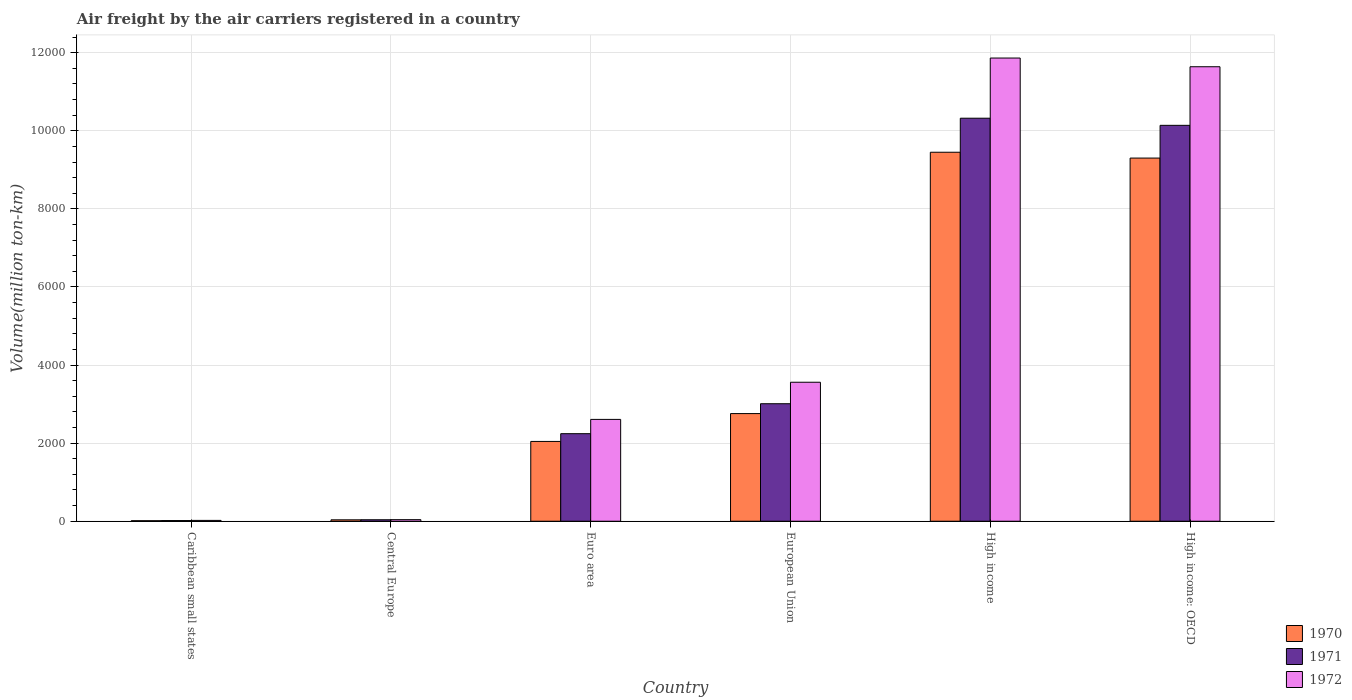How many different coloured bars are there?
Your response must be concise. 3. Are the number of bars per tick equal to the number of legend labels?
Provide a succinct answer. Yes. How many bars are there on the 5th tick from the left?
Your response must be concise. 3. What is the label of the 6th group of bars from the left?
Offer a very short reply. High income: OECD. In how many cases, is the number of bars for a given country not equal to the number of legend labels?
Your response must be concise. 0. What is the volume of the air carriers in 1971 in Euro area?
Make the answer very short. 2242.1. Across all countries, what is the maximum volume of the air carriers in 1972?
Offer a terse response. 1.19e+04. Across all countries, what is the minimum volume of the air carriers in 1972?
Give a very brief answer. 21.4. In which country was the volume of the air carriers in 1972 maximum?
Your answer should be compact. High income. In which country was the volume of the air carriers in 1972 minimum?
Give a very brief answer. Caribbean small states. What is the total volume of the air carriers in 1970 in the graph?
Offer a very short reply. 2.36e+04. What is the difference between the volume of the air carriers in 1971 in Caribbean small states and that in High income: OECD?
Your answer should be compact. -1.01e+04. What is the difference between the volume of the air carriers in 1970 in Caribbean small states and the volume of the air carriers in 1972 in Central Europe?
Your answer should be very brief. -26.7. What is the average volume of the air carriers in 1971 per country?
Your answer should be very brief. 4294.62. What is the difference between the volume of the air carriers of/in 1970 and volume of the air carriers of/in 1971 in European Union?
Offer a very short reply. -252.6. In how many countries, is the volume of the air carriers in 1970 greater than 8000 million ton-km?
Your response must be concise. 2. What is the ratio of the volume of the air carriers in 1972 in High income to that in High income: OECD?
Your answer should be compact. 1.02. Is the volume of the air carriers in 1971 in Central Europe less than that in Euro area?
Offer a very short reply. Yes. What is the difference between the highest and the second highest volume of the air carriers in 1971?
Your answer should be very brief. 182.7. What is the difference between the highest and the lowest volume of the air carriers in 1972?
Your response must be concise. 1.18e+04. In how many countries, is the volume of the air carriers in 1970 greater than the average volume of the air carriers in 1970 taken over all countries?
Offer a terse response. 2. Is it the case that in every country, the sum of the volume of the air carriers in 1972 and volume of the air carriers in 1970 is greater than the volume of the air carriers in 1971?
Ensure brevity in your answer.  Yes. Are all the bars in the graph horizontal?
Your response must be concise. No. Are the values on the major ticks of Y-axis written in scientific E-notation?
Keep it short and to the point. No. Does the graph contain grids?
Ensure brevity in your answer.  Yes. How are the legend labels stacked?
Give a very brief answer. Vertical. What is the title of the graph?
Offer a terse response. Air freight by the air carriers registered in a country. What is the label or title of the X-axis?
Offer a very short reply. Country. What is the label or title of the Y-axis?
Your response must be concise. Volume(million ton-km). What is the Volume(million ton-km) of 1970 in Caribbean small states?
Your answer should be compact. 13.4. What is the Volume(million ton-km) of 1971 in Caribbean small states?
Provide a succinct answer. 17.2. What is the Volume(million ton-km) in 1972 in Caribbean small states?
Offer a very short reply. 21.4. What is the Volume(million ton-km) of 1970 in Central Europe?
Provide a succinct answer. 36. What is the Volume(million ton-km) in 1971 in Central Europe?
Give a very brief answer. 37.9. What is the Volume(million ton-km) of 1972 in Central Europe?
Offer a very short reply. 40.1. What is the Volume(million ton-km) of 1970 in Euro area?
Your response must be concise. 2043.6. What is the Volume(million ton-km) of 1971 in Euro area?
Ensure brevity in your answer.  2242.1. What is the Volume(million ton-km) of 1972 in Euro area?
Your answer should be very brief. 2607.9. What is the Volume(million ton-km) of 1970 in European Union?
Make the answer very short. 2756.8. What is the Volume(million ton-km) of 1971 in European Union?
Give a very brief answer. 3009.4. What is the Volume(million ton-km) in 1972 in European Union?
Give a very brief answer. 3559.6. What is the Volume(million ton-km) of 1970 in High income?
Your answer should be very brief. 9450. What is the Volume(million ton-km) in 1971 in High income?
Your response must be concise. 1.03e+04. What is the Volume(million ton-km) of 1972 in High income?
Ensure brevity in your answer.  1.19e+04. What is the Volume(million ton-km) of 1970 in High income: OECD?
Make the answer very short. 9300.9. What is the Volume(million ton-km) in 1971 in High income: OECD?
Your response must be concise. 1.01e+04. What is the Volume(million ton-km) in 1972 in High income: OECD?
Your answer should be compact. 1.16e+04. Across all countries, what is the maximum Volume(million ton-km) in 1970?
Give a very brief answer. 9450. Across all countries, what is the maximum Volume(million ton-km) in 1971?
Give a very brief answer. 1.03e+04. Across all countries, what is the maximum Volume(million ton-km) in 1972?
Keep it short and to the point. 1.19e+04. Across all countries, what is the minimum Volume(million ton-km) of 1970?
Give a very brief answer. 13.4. Across all countries, what is the minimum Volume(million ton-km) in 1971?
Your response must be concise. 17.2. Across all countries, what is the minimum Volume(million ton-km) in 1972?
Ensure brevity in your answer.  21.4. What is the total Volume(million ton-km) in 1970 in the graph?
Your answer should be compact. 2.36e+04. What is the total Volume(million ton-km) in 1971 in the graph?
Your answer should be very brief. 2.58e+04. What is the total Volume(million ton-km) in 1972 in the graph?
Offer a very short reply. 2.97e+04. What is the difference between the Volume(million ton-km) of 1970 in Caribbean small states and that in Central Europe?
Make the answer very short. -22.6. What is the difference between the Volume(million ton-km) in 1971 in Caribbean small states and that in Central Europe?
Provide a succinct answer. -20.7. What is the difference between the Volume(million ton-km) of 1972 in Caribbean small states and that in Central Europe?
Make the answer very short. -18.7. What is the difference between the Volume(million ton-km) in 1970 in Caribbean small states and that in Euro area?
Your answer should be compact. -2030.2. What is the difference between the Volume(million ton-km) in 1971 in Caribbean small states and that in Euro area?
Provide a succinct answer. -2224.9. What is the difference between the Volume(million ton-km) of 1972 in Caribbean small states and that in Euro area?
Give a very brief answer. -2586.5. What is the difference between the Volume(million ton-km) of 1970 in Caribbean small states and that in European Union?
Keep it short and to the point. -2743.4. What is the difference between the Volume(million ton-km) of 1971 in Caribbean small states and that in European Union?
Offer a very short reply. -2992.2. What is the difference between the Volume(million ton-km) in 1972 in Caribbean small states and that in European Union?
Ensure brevity in your answer.  -3538.2. What is the difference between the Volume(million ton-km) in 1970 in Caribbean small states and that in High income?
Keep it short and to the point. -9436.6. What is the difference between the Volume(million ton-km) of 1971 in Caribbean small states and that in High income?
Your answer should be compact. -1.03e+04. What is the difference between the Volume(million ton-km) in 1972 in Caribbean small states and that in High income?
Provide a short and direct response. -1.18e+04. What is the difference between the Volume(million ton-km) of 1970 in Caribbean small states and that in High income: OECD?
Your response must be concise. -9287.5. What is the difference between the Volume(million ton-km) in 1971 in Caribbean small states and that in High income: OECD?
Offer a very short reply. -1.01e+04. What is the difference between the Volume(million ton-km) of 1972 in Caribbean small states and that in High income: OECD?
Your response must be concise. -1.16e+04. What is the difference between the Volume(million ton-km) in 1970 in Central Europe and that in Euro area?
Make the answer very short. -2007.6. What is the difference between the Volume(million ton-km) in 1971 in Central Europe and that in Euro area?
Keep it short and to the point. -2204.2. What is the difference between the Volume(million ton-km) in 1972 in Central Europe and that in Euro area?
Offer a terse response. -2567.8. What is the difference between the Volume(million ton-km) of 1970 in Central Europe and that in European Union?
Provide a succinct answer. -2720.8. What is the difference between the Volume(million ton-km) in 1971 in Central Europe and that in European Union?
Your response must be concise. -2971.5. What is the difference between the Volume(million ton-km) of 1972 in Central Europe and that in European Union?
Provide a succinct answer. -3519.5. What is the difference between the Volume(million ton-km) of 1970 in Central Europe and that in High income?
Provide a short and direct response. -9414. What is the difference between the Volume(million ton-km) of 1971 in Central Europe and that in High income?
Ensure brevity in your answer.  -1.03e+04. What is the difference between the Volume(million ton-km) in 1972 in Central Europe and that in High income?
Keep it short and to the point. -1.18e+04. What is the difference between the Volume(million ton-km) of 1970 in Central Europe and that in High income: OECD?
Keep it short and to the point. -9264.9. What is the difference between the Volume(million ton-km) in 1971 in Central Europe and that in High income: OECD?
Your answer should be compact. -1.01e+04. What is the difference between the Volume(million ton-km) of 1972 in Central Europe and that in High income: OECD?
Keep it short and to the point. -1.16e+04. What is the difference between the Volume(million ton-km) of 1970 in Euro area and that in European Union?
Make the answer very short. -713.2. What is the difference between the Volume(million ton-km) in 1971 in Euro area and that in European Union?
Give a very brief answer. -767.3. What is the difference between the Volume(million ton-km) in 1972 in Euro area and that in European Union?
Keep it short and to the point. -951.7. What is the difference between the Volume(million ton-km) of 1970 in Euro area and that in High income?
Provide a succinct answer. -7406.4. What is the difference between the Volume(million ton-km) in 1971 in Euro area and that in High income?
Keep it short and to the point. -8079.8. What is the difference between the Volume(million ton-km) in 1972 in Euro area and that in High income?
Make the answer very short. -9255. What is the difference between the Volume(million ton-km) in 1970 in Euro area and that in High income: OECD?
Make the answer very short. -7257.3. What is the difference between the Volume(million ton-km) in 1971 in Euro area and that in High income: OECD?
Provide a succinct answer. -7897.1. What is the difference between the Volume(million ton-km) of 1972 in Euro area and that in High income: OECD?
Offer a terse response. -9031.8. What is the difference between the Volume(million ton-km) of 1970 in European Union and that in High income?
Keep it short and to the point. -6693.2. What is the difference between the Volume(million ton-km) of 1971 in European Union and that in High income?
Your response must be concise. -7312.5. What is the difference between the Volume(million ton-km) of 1972 in European Union and that in High income?
Offer a very short reply. -8303.3. What is the difference between the Volume(million ton-km) in 1970 in European Union and that in High income: OECD?
Your response must be concise. -6544.1. What is the difference between the Volume(million ton-km) in 1971 in European Union and that in High income: OECD?
Offer a very short reply. -7129.8. What is the difference between the Volume(million ton-km) in 1972 in European Union and that in High income: OECD?
Provide a succinct answer. -8080.1. What is the difference between the Volume(million ton-km) in 1970 in High income and that in High income: OECD?
Offer a terse response. 149.1. What is the difference between the Volume(million ton-km) in 1971 in High income and that in High income: OECD?
Your answer should be compact. 182.7. What is the difference between the Volume(million ton-km) in 1972 in High income and that in High income: OECD?
Ensure brevity in your answer.  223.2. What is the difference between the Volume(million ton-km) of 1970 in Caribbean small states and the Volume(million ton-km) of 1971 in Central Europe?
Keep it short and to the point. -24.5. What is the difference between the Volume(million ton-km) of 1970 in Caribbean small states and the Volume(million ton-km) of 1972 in Central Europe?
Your answer should be compact. -26.7. What is the difference between the Volume(million ton-km) of 1971 in Caribbean small states and the Volume(million ton-km) of 1972 in Central Europe?
Give a very brief answer. -22.9. What is the difference between the Volume(million ton-km) in 1970 in Caribbean small states and the Volume(million ton-km) in 1971 in Euro area?
Offer a terse response. -2228.7. What is the difference between the Volume(million ton-km) of 1970 in Caribbean small states and the Volume(million ton-km) of 1972 in Euro area?
Your answer should be compact. -2594.5. What is the difference between the Volume(million ton-km) of 1971 in Caribbean small states and the Volume(million ton-km) of 1972 in Euro area?
Offer a very short reply. -2590.7. What is the difference between the Volume(million ton-km) in 1970 in Caribbean small states and the Volume(million ton-km) in 1971 in European Union?
Ensure brevity in your answer.  -2996. What is the difference between the Volume(million ton-km) in 1970 in Caribbean small states and the Volume(million ton-km) in 1972 in European Union?
Your answer should be compact. -3546.2. What is the difference between the Volume(million ton-km) in 1971 in Caribbean small states and the Volume(million ton-km) in 1972 in European Union?
Give a very brief answer. -3542.4. What is the difference between the Volume(million ton-km) in 1970 in Caribbean small states and the Volume(million ton-km) in 1971 in High income?
Provide a short and direct response. -1.03e+04. What is the difference between the Volume(million ton-km) of 1970 in Caribbean small states and the Volume(million ton-km) of 1972 in High income?
Keep it short and to the point. -1.18e+04. What is the difference between the Volume(million ton-km) of 1971 in Caribbean small states and the Volume(million ton-km) of 1972 in High income?
Give a very brief answer. -1.18e+04. What is the difference between the Volume(million ton-km) of 1970 in Caribbean small states and the Volume(million ton-km) of 1971 in High income: OECD?
Ensure brevity in your answer.  -1.01e+04. What is the difference between the Volume(million ton-km) of 1970 in Caribbean small states and the Volume(million ton-km) of 1972 in High income: OECD?
Give a very brief answer. -1.16e+04. What is the difference between the Volume(million ton-km) of 1971 in Caribbean small states and the Volume(million ton-km) of 1972 in High income: OECD?
Keep it short and to the point. -1.16e+04. What is the difference between the Volume(million ton-km) in 1970 in Central Europe and the Volume(million ton-km) in 1971 in Euro area?
Give a very brief answer. -2206.1. What is the difference between the Volume(million ton-km) of 1970 in Central Europe and the Volume(million ton-km) of 1972 in Euro area?
Your response must be concise. -2571.9. What is the difference between the Volume(million ton-km) in 1971 in Central Europe and the Volume(million ton-km) in 1972 in Euro area?
Your response must be concise. -2570. What is the difference between the Volume(million ton-km) in 1970 in Central Europe and the Volume(million ton-km) in 1971 in European Union?
Your answer should be very brief. -2973.4. What is the difference between the Volume(million ton-km) in 1970 in Central Europe and the Volume(million ton-km) in 1972 in European Union?
Offer a very short reply. -3523.6. What is the difference between the Volume(million ton-km) in 1971 in Central Europe and the Volume(million ton-km) in 1972 in European Union?
Give a very brief answer. -3521.7. What is the difference between the Volume(million ton-km) in 1970 in Central Europe and the Volume(million ton-km) in 1971 in High income?
Provide a short and direct response. -1.03e+04. What is the difference between the Volume(million ton-km) in 1970 in Central Europe and the Volume(million ton-km) in 1972 in High income?
Give a very brief answer. -1.18e+04. What is the difference between the Volume(million ton-km) in 1971 in Central Europe and the Volume(million ton-km) in 1972 in High income?
Your response must be concise. -1.18e+04. What is the difference between the Volume(million ton-km) in 1970 in Central Europe and the Volume(million ton-km) in 1971 in High income: OECD?
Provide a succinct answer. -1.01e+04. What is the difference between the Volume(million ton-km) of 1970 in Central Europe and the Volume(million ton-km) of 1972 in High income: OECD?
Keep it short and to the point. -1.16e+04. What is the difference between the Volume(million ton-km) of 1971 in Central Europe and the Volume(million ton-km) of 1972 in High income: OECD?
Keep it short and to the point. -1.16e+04. What is the difference between the Volume(million ton-km) in 1970 in Euro area and the Volume(million ton-km) in 1971 in European Union?
Offer a terse response. -965.8. What is the difference between the Volume(million ton-km) in 1970 in Euro area and the Volume(million ton-km) in 1972 in European Union?
Ensure brevity in your answer.  -1516. What is the difference between the Volume(million ton-km) of 1971 in Euro area and the Volume(million ton-km) of 1972 in European Union?
Your answer should be very brief. -1317.5. What is the difference between the Volume(million ton-km) of 1970 in Euro area and the Volume(million ton-km) of 1971 in High income?
Your response must be concise. -8278.3. What is the difference between the Volume(million ton-km) in 1970 in Euro area and the Volume(million ton-km) in 1972 in High income?
Give a very brief answer. -9819.3. What is the difference between the Volume(million ton-km) in 1971 in Euro area and the Volume(million ton-km) in 1972 in High income?
Make the answer very short. -9620.8. What is the difference between the Volume(million ton-km) in 1970 in Euro area and the Volume(million ton-km) in 1971 in High income: OECD?
Offer a very short reply. -8095.6. What is the difference between the Volume(million ton-km) of 1970 in Euro area and the Volume(million ton-km) of 1972 in High income: OECD?
Keep it short and to the point. -9596.1. What is the difference between the Volume(million ton-km) in 1971 in Euro area and the Volume(million ton-km) in 1972 in High income: OECD?
Keep it short and to the point. -9397.6. What is the difference between the Volume(million ton-km) of 1970 in European Union and the Volume(million ton-km) of 1971 in High income?
Ensure brevity in your answer.  -7565.1. What is the difference between the Volume(million ton-km) in 1970 in European Union and the Volume(million ton-km) in 1972 in High income?
Offer a terse response. -9106.1. What is the difference between the Volume(million ton-km) in 1971 in European Union and the Volume(million ton-km) in 1972 in High income?
Keep it short and to the point. -8853.5. What is the difference between the Volume(million ton-km) of 1970 in European Union and the Volume(million ton-km) of 1971 in High income: OECD?
Give a very brief answer. -7382.4. What is the difference between the Volume(million ton-km) in 1970 in European Union and the Volume(million ton-km) in 1972 in High income: OECD?
Give a very brief answer. -8882.9. What is the difference between the Volume(million ton-km) in 1971 in European Union and the Volume(million ton-km) in 1972 in High income: OECD?
Your answer should be compact. -8630.3. What is the difference between the Volume(million ton-km) in 1970 in High income and the Volume(million ton-km) in 1971 in High income: OECD?
Offer a very short reply. -689.2. What is the difference between the Volume(million ton-km) of 1970 in High income and the Volume(million ton-km) of 1972 in High income: OECD?
Make the answer very short. -2189.7. What is the difference between the Volume(million ton-km) of 1971 in High income and the Volume(million ton-km) of 1972 in High income: OECD?
Provide a short and direct response. -1317.8. What is the average Volume(million ton-km) of 1970 per country?
Make the answer very short. 3933.45. What is the average Volume(million ton-km) in 1971 per country?
Your response must be concise. 4294.62. What is the average Volume(million ton-km) of 1972 per country?
Your answer should be compact. 4955.27. What is the difference between the Volume(million ton-km) in 1970 and Volume(million ton-km) in 1972 in Caribbean small states?
Provide a short and direct response. -8. What is the difference between the Volume(million ton-km) of 1971 and Volume(million ton-km) of 1972 in Caribbean small states?
Offer a very short reply. -4.2. What is the difference between the Volume(million ton-km) in 1970 and Volume(million ton-km) in 1971 in Central Europe?
Ensure brevity in your answer.  -1.9. What is the difference between the Volume(million ton-km) in 1970 and Volume(million ton-km) in 1972 in Central Europe?
Make the answer very short. -4.1. What is the difference between the Volume(million ton-km) of 1970 and Volume(million ton-km) of 1971 in Euro area?
Give a very brief answer. -198.5. What is the difference between the Volume(million ton-km) of 1970 and Volume(million ton-km) of 1972 in Euro area?
Offer a terse response. -564.3. What is the difference between the Volume(million ton-km) of 1971 and Volume(million ton-km) of 1972 in Euro area?
Provide a short and direct response. -365.8. What is the difference between the Volume(million ton-km) in 1970 and Volume(million ton-km) in 1971 in European Union?
Make the answer very short. -252.6. What is the difference between the Volume(million ton-km) in 1970 and Volume(million ton-km) in 1972 in European Union?
Give a very brief answer. -802.8. What is the difference between the Volume(million ton-km) in 1971 and Volume(million ton-km) in 1972 in European Union?
Provide a succinct answer. -550.2. What is the difference between the Volume(million ton-km) in 1970 and Volume(million ton-km) in 1971 in High income?
Give a very brief answer. -871.9. What is the difference between the Volume(million ton-km) of 1970 and Volume(million ton-km) of 1972 in High income?
Your answer should be very brief. -2412.9. What is the difference between the Volume(million ton-km) of 1971 and Volume(million ton-km) of 1972 in High income?
Provide a short and direct response. -1541. What is the difference between the Volume(million ton-km) of 1970 and Volume(million ton-km) of 1971 in High income: OECD?
Provide a succinct answer. -838.3. What is the difference between the Volume(million ton-km) in 1970 and Volume(million ton-km) in 1972 in High income: OECD?
Provide a short and direct response. -2338.8. What is the difference between the Volume(million ton-km) of 1971 and Volume(million ton-km) of 1972 in High income: OECD?
Keep it short and to the point. -1500.5. What is the ratio of the Volume(million ton-km) of 1970 in Caribbean small states to that in Central Europe?
Offer a very short reply. 0.37. What is the ratio of the Volume(million ton-km) in 1971 in Caribbean small states to that in Central Europe?
Provide a succinct answer. 0.45. What is the ratio of the Volume(million ton-km) of 1972 in Caribbean small states to that in Central Europe?
Make the answer very short. 0.53. What is the ratio of the Volume(million ton-km) in 1970 in Caribbean small states to that in Euro area?
Provide a short and direct response. 0.01. What is the ratio of the Volume(million ton-km) of 1971 in Caribbean small states to that in Euro area?
Provide a succinct answer. 0.01. What is the ratio of the Volume(million ton-km) of 1972 in Caribbean small states to that in Euro area?
Your answer should be compact. 0.01. What is the ratio of the Volume(million ton-km) in 1970 in Caribbean small states to that in European Union?
Your answer should be compact. 0. What is the ratio of the Volume(million ton-km) of 1971 in Caribbean small states to that in European Union?
Your answer should be very brief. 0.01. What is the ratio of the Volume(million ton-km) in 1972 in Caribbean small states to that in European Union?
Make the answer very short. 0.01. What is the ratio of the Volume(million ton-km) of 1970 in Caribbean small states to that in High income?
Offer a very short reply. 0. What is the ratio of the Volume(million ton-km) in 1971 in Caribbean small states to that in High income?
Give a very brief answer. 0. What is the ratio of the Volume(million ton-km) in 1972 in Caribbean small states to that in High income?
Make the answer very short. 0. What is the ratio of the Volume(million ton-km) of 1970 in Caribbean small states to that in High income: OECD?
Your answer should be compact. 0. What is the ratio of the Volume(million ton-km) in 1971 in Caribbean small states to that in High income: OECD?
Provide a succinct answer. 0. What is the ratio of the Volume(million ton-km) in 1972 in Caribbean small states to that in High income: OECD?
Your answer should be very brief. 0. What is the ratio of the Volume(million ton-km) in 1970 in Central Europe to that in Euro area?
Offer a terse response. 0.02. What is the ratio of the Volume(million ton-km) of 1971 in Central Europe to that in Euro area?
Give a very brief answer. 0.02. What is the ratio of the Volume(million ton-km) of 1972 in Central Europe to that in Euro area?
Offer a very short reply. 0.02. What is the ratio of the Volume(million ton-km) in 1970 in Central Europe to that in European Union?
Give a very brief answer. 0.01. What is the ratio of the Volume(million ton-km) in 1971 in Central Europe to that in European Union?
Provide a short and direct response. 0.01. What is the ratio of the Volume(million ton-km) in 1972 in Central Europe to that in European Union?
Ensure brevity in your answer.  0.01. What is the ratio of the Volume(million ton-km) of 1970 in Central Europe to that in High income?
Your answer should be compact. 0. What is the ratio of the Volume(million ton-km) of 1971 in Central Europe to that in High income?
Provide a short and direct response. 0. What is the ratio of the Volume(million ton-km) in 1972 in Central Europe to that in High income?
Your response must be concise. 0. What is the ratio of the Volume(million ton-km) of 1970 in Central Europe to that in High income: OECD?
Your answer should be compact. 0. What is the ratio of the Volume(million ton-km) of 1971 in Central Europe to that in High income: OECD?
Keep it short and to the point. 0. What is the ratio of the Volume(million ton-km) in 1972 in Central Europe to that in High income: OECD?
Provide a succinct answer. 0. What is the ratio of the Volume(million ton-km) of 1970 in Euro area to that in European Union?
Make the answer very short. 0.74. What is the ratio of the Volume(million ton-km) in 1971 in Euro area to that in European Union?
Keep it short and to the point. 0.74. What is the ratio of the Volume(million ton-km) in 1972 in Euro area to that in European Union?
Keep it short and to the point. 0.73. What is the ratio of the Volume(million ton-km) in 1970 in Euro area to that in High income?
Your answer should be compact. 0.22. What is the ratio of the Volume(million ton-km) in 1971 in Euro area to that in High income?
Make the answer very short. 0.22. What is the ratio of the Volume(million ton-km) of 1972 in Euro area to that in High income?
Offer a terse response. 0.22. What is the ratio of the Volume(million ton-km) in 1970 in Euro area to that in High income: OECD?
Keep it short and to the point. 0.22. What is the ratio of the Volume(million ton-km) in 1971 in Euro area to that in High income: OECD?
Make the answer very short. 0.22. What is the ratio of the Volume(million ton-km) of 1972 in Euro area to that in High income: OECD?
Make the answer very short. 0.22. What is the ratio of the Volume(million ton-km) of 1970 in European Union to that in High income?
Offer a terse response. 0.29. What is the ratio of the Volume(million ton-km) in 1971 in European Union to that in High income?
Your response must be concise. 0.29. What is the ratio of the Volume(million ton-km) of 1972 in European Union to that in High income?
Give a very brief answer. 0.3. What is the ratio of the Volume(million ton-km) in 1970 in European Union to that in High income: OECD?
Ensure brevity in your answer.  0.3. What is the ratio of the Volume(million ton-km) in 1971 in European Union to that in High income: OECD?
Offer a terse response. 0.3. What is the ratio of the Volume(million ton-km) in 1972 in European Union to that in High income: OECD?
Your response must be concise. 0.31. What is the ratio of the Volume(million ton-km) of 1972 in High income to that in High income: OECD?
Provide a short and direct response. 1.02. What is the difference between the highest and the second highest Volume(million ton-km) in 1970?
Offer a terse response. 149.1. What is the difference between the highest and the second highest Volume(million ton-km) in 1971?
Make the answer very short. 182.7. What is the difference between the highest and the second highest Volume(million ton-km) in 1972?
Make the answer very short. 223.2. What is the difference between the highest and the lowest Volume(million ton-km) in 1970?
Your answer should be compact. 9436.6. What is the difference between the highest and the lowest Volume(million ton-km) in 1971?
Make the answer very short. 1.03e+04. What is the difference between the highest and the lowest Volume(million ton-km) of 1972?
Offer a very short reply. 1.18e+04. 